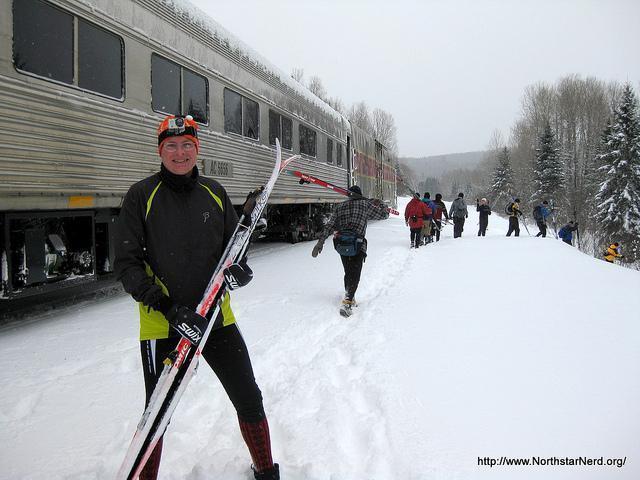How did these skiers get to this location?
Indicate the correct choice and explain in the format: 'Answer: answer
Rationale: rationale.'
Options: Ski lift, train, uber, bus. Answer: train.
Rationale: They took a train that they are standing next to. 